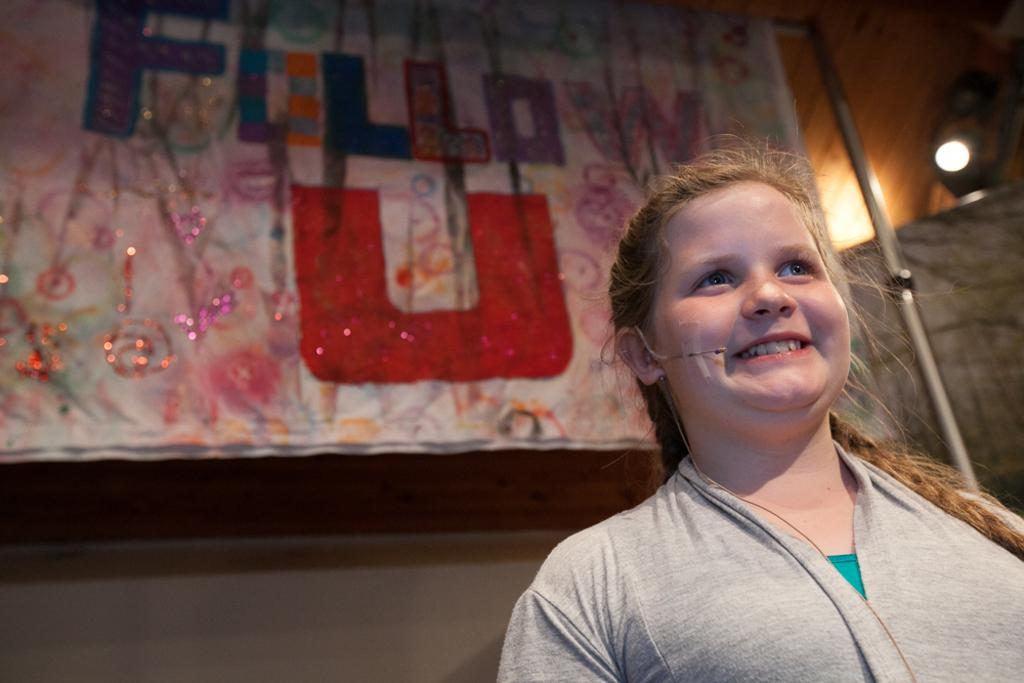Who is the main subject in the image? There is a girl in the middle of the image. What can be seen in the background of the image? There is a cloth in the background of the image. What is special about the cloth? The cloth has some text and decoration on it. Where is the light source in the image? There is a light on the right side top of the image. What type of music is the girl playing in the image? There is no music or musical instrument visible in the image. 